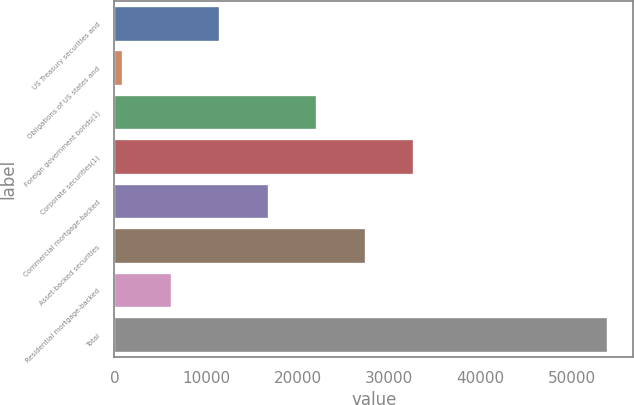Convert chart. <chart><loc_0><loc_0><loc_500><loc_500><bar_chart><fcel>US Treasury securities and<fcel>Obligations of US states and<fcel>Foreign government bonds(1)<fcel>Corporate securities(1)<fcel>Commercial mortgage-backed<fcel>Asset-backed securities<fcel>Residential mortgage-backed<fcel>Total<nl><fcel>11545.2<fcel>943<fcel>22147.4<fcel>32749.6<fcel>16846.3<fcel>27448.5<fcel>6244.1<fcel>53954<nl></chart> 